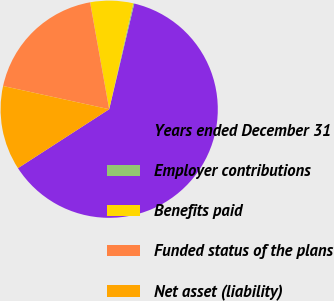Convert chart to OTSL. <chart><loc_0><loc_0><loc_500><loc_500><pie_chart><fcel>Years ended December 31<fcel>Employer contributions<fcel>Benefits paid<fcel>Funded status of the plans<fcel>Net asset (liability)<nl><fcel>62.17%<fcel>0.16%<fcel>6.36%<fcel>18.76%<fcel>12.56%<nl></chart> 